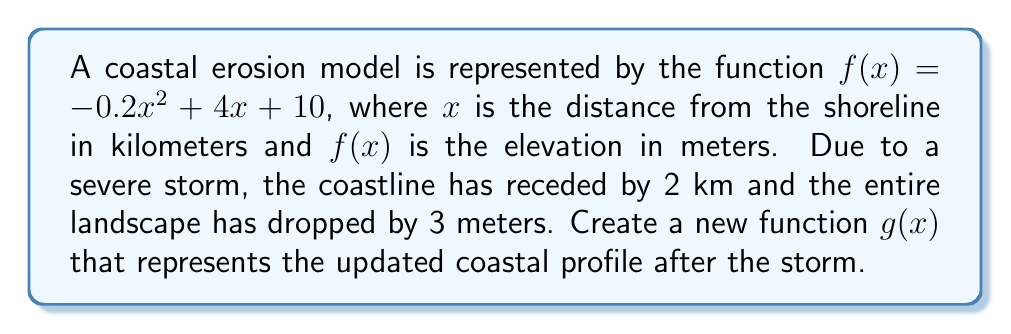Can you solve this math problem? To create the new function $g(x)$, we need to apply two transformations to $f(x)$:

1. Translate horizontally by 2 km to represent the coastline recession:
   Replace $x$ with $(x-2)$
   $f(x-2) = -0.2(x-2)^2 + 4(x-2) + 10$

2. Translate vertically by -3 meters to represent the landscape dropping:
   Subtract 3 from the entire function
   $g(x) = f(x-2) - 3$

Now, let's expand and simplify:

$g(x) = -0.2(x-2)^2 + 4(x-2) + 10 - 3$

$g(x) = -0.2(x^2 - 4x + 4) + 4x - 8 + 7$

$g(x) = -0.2x^2 + 0.8x - 0.8 + 4x - 8 + 7$

$g(x) = -0.2x^2 + 4.8x - 1.8$

Therefore, the new function representing the updated coastal profile is:

$g(x) = -0.2x^2 + 4.8x - 1.8$
Answer: $g(x) = -0.2x^2 + 4.8x - 1.8$ 